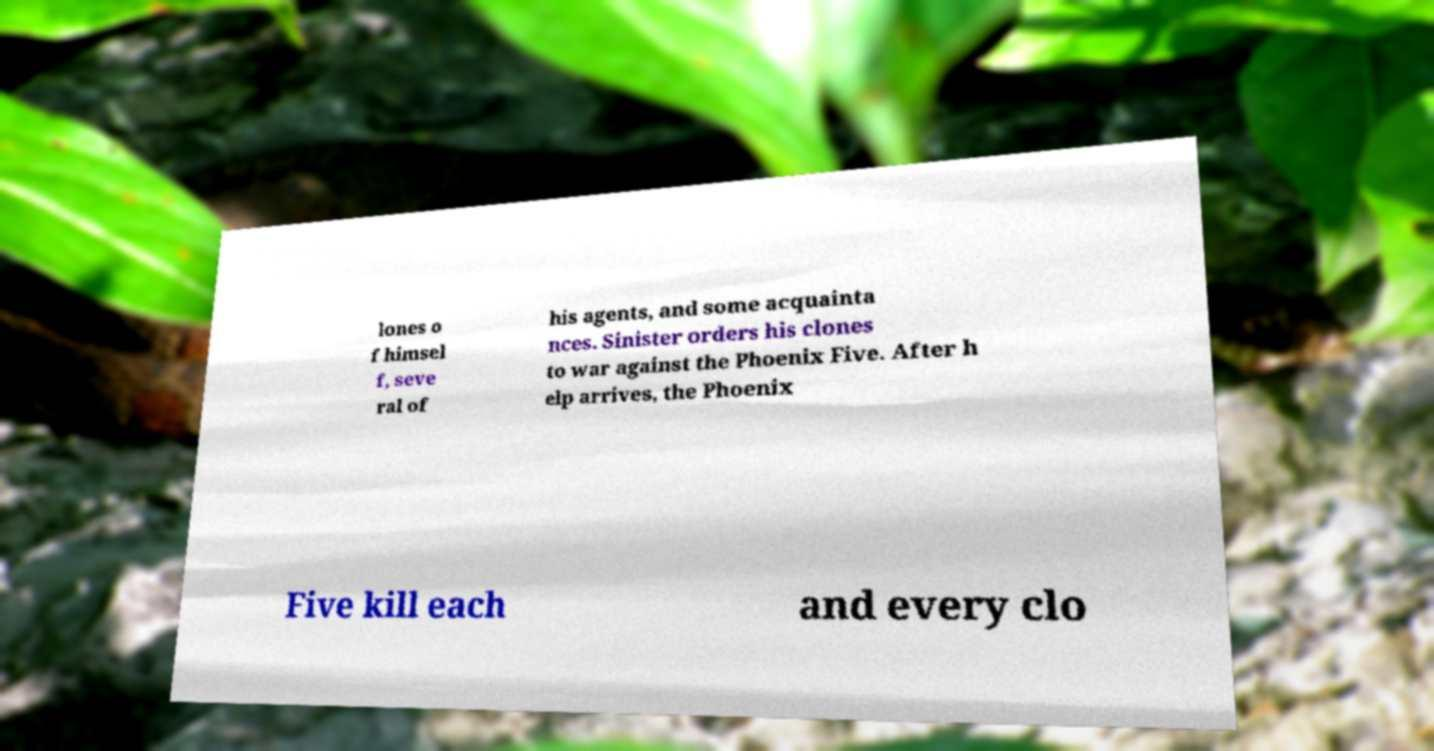Can you read and provide the text displayed in the image?This photo seems to have some interesting text. Can you extract and type it out for me? lones o f himsel f, seve ral of his agents, and some acquainta nces. Sinister orders his clones to war against the Phoenix Five. After h elp arrives, the Phoenix Five kill each and every clo 